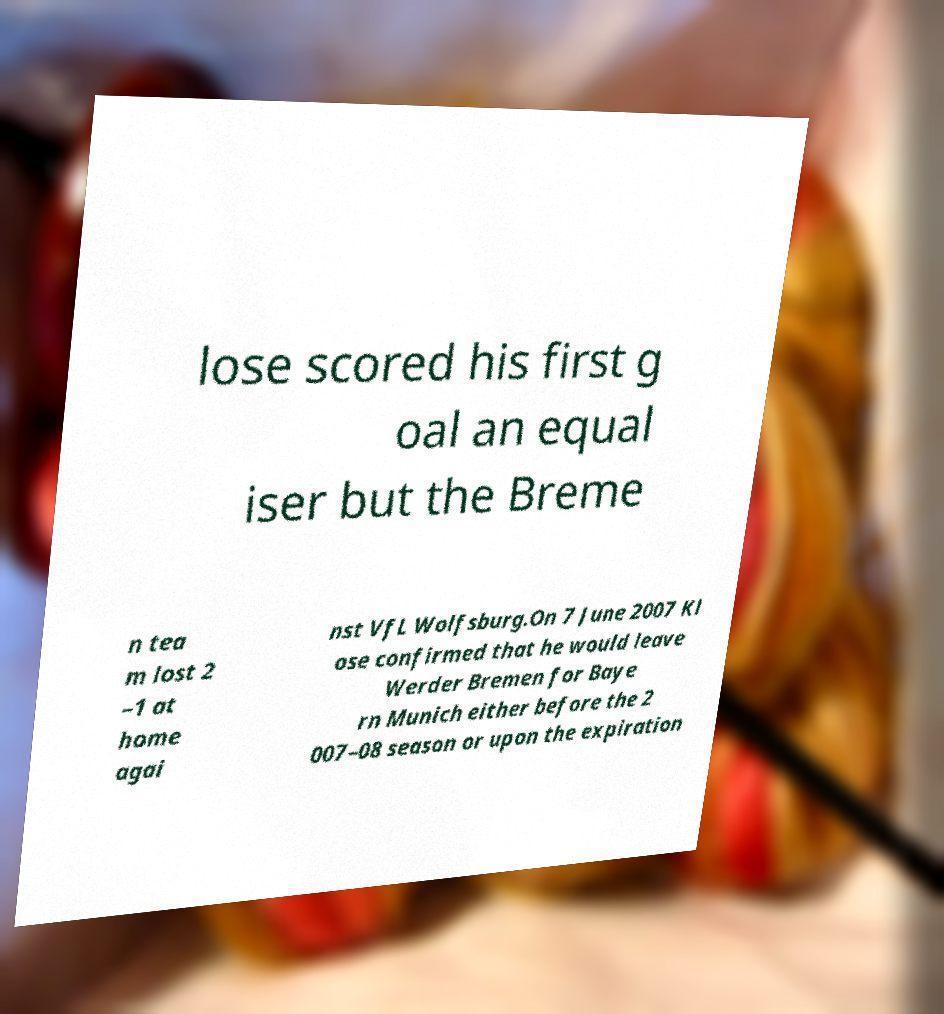I need the written content from this picture converted into text. Can you do that? lose scored his first g oal an equal iser but the Breme n tea m lost 2 –1 at home agai nst VfL Wolfsburg.On 7 June 2007 Kl ose confirmed that he would leave Werder Bremen for Baye rn Munich either before the 2 007–08 season or upon the expiration 